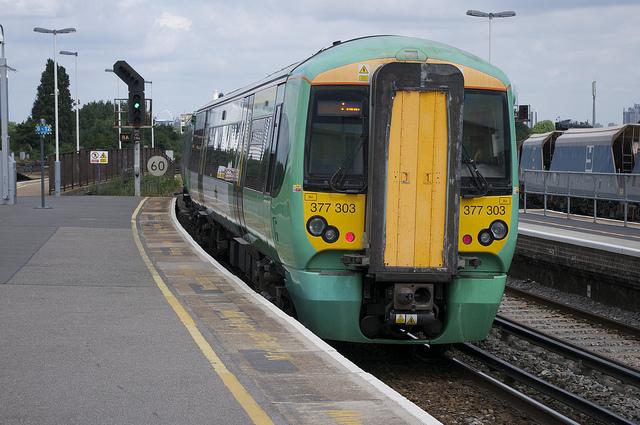What number is the bus?
Be succinct. 377 303. What color shows on the stoplight?
Keep it brief. Green. Is this the front or back of the train?
Keep it brief. Back. 